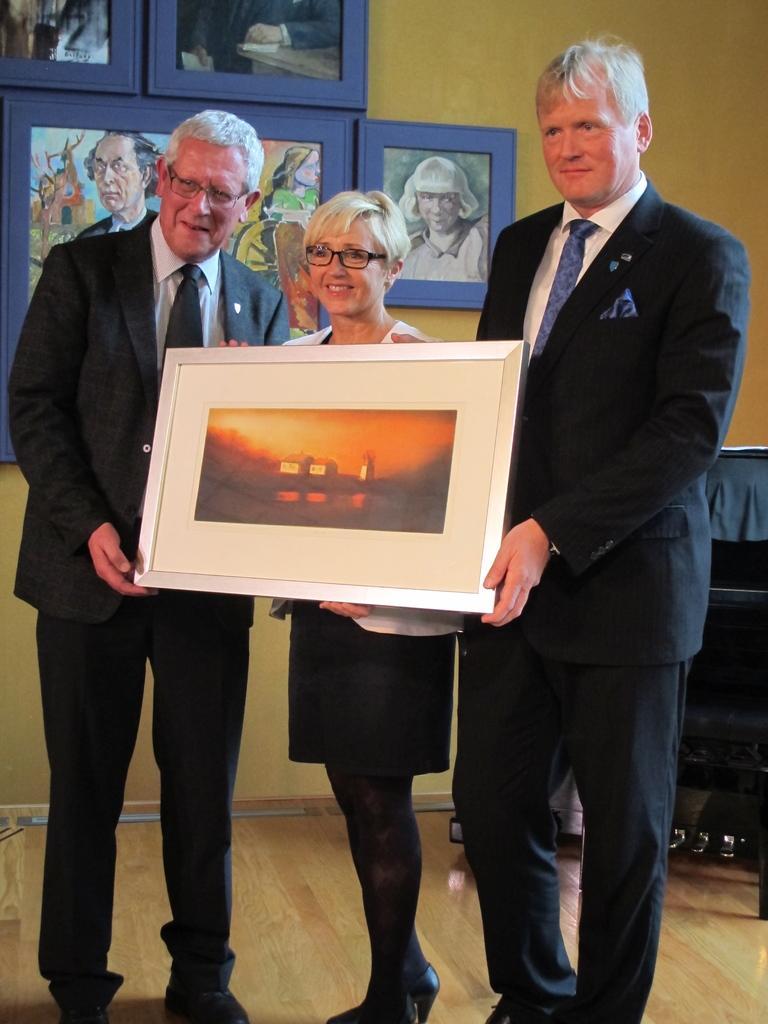Can you describe this image briefly? In this image I can see three people with different color dresses. I can see two people are wearing the blazers and these people are holding the frame. In the back I can see few frames to the yellow color wall. 